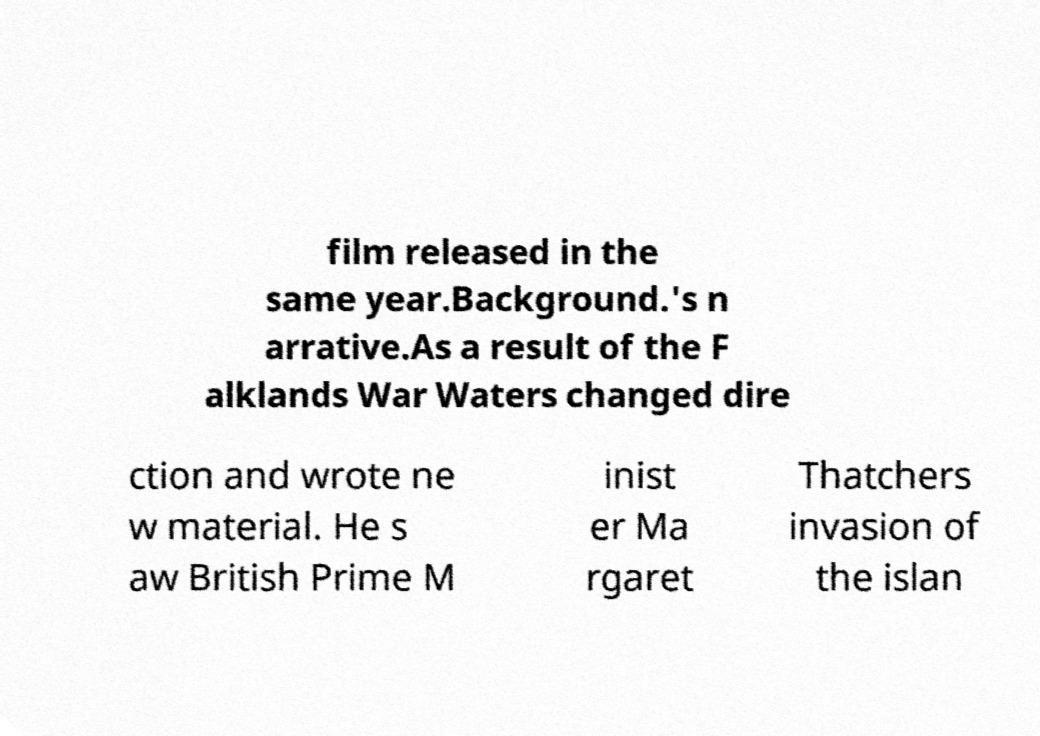I need the written content from this picture converted into text. Can you do that? film released in the same year.Background.'s n arrative.As a result of the F alklands War Waters changed dire ction and wrote ne w material. He s aw British Prime M inist er Ma rgaret Thatchers invasion of the islan 